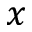Convert formula to latex. <formula><loc_0><loc_0><loc_500><loc_500>x</formula> 